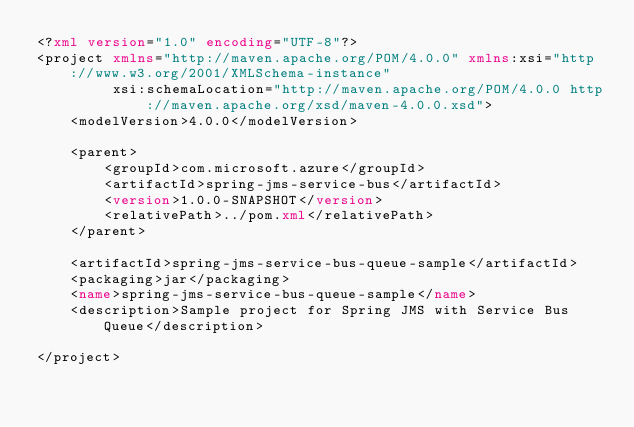Convert code to text. <code><loc_0><loc_0><loc_500><loc_500><_XML_><?xml version="1.0" encoding="UTF-8"?>
<project xmlns="http://maven.apache.org/POM/4.0.0" xmlns:xsi="http://www.w3.org/2001/XMLSchema-instance"
         xsi:schemaLocation="http://maven.apache.org/POM/4.0.0 http://maven.apache.org/xsd/maven-4.0.0.xsd">
    <modelVersion>4.0.0</modelVersion>

    <parent>
        <groupId>com.microsoft.azure</groupId>
        <artifactId>spring-jms-service-bus</artifactId>
        <version>1.0.0-SNAPSHOT</version>
        <relativePath>../pom.xml</relativePath>
    </parent>

    <artifactId>spring-jms-service-bus-queue-sample</artifactId>
    <packaging>jar</packaging>
    <name>spring-jms-service-bus-queue-sample</name>
    <description>Sample project for Spring JMS with Service Bus Queue</description>

</project>
</code> 